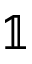Convert formula to latex. <formula><loc_0><loc_0><loc_500><loc_500>\mathbb { 1 }</formula> 